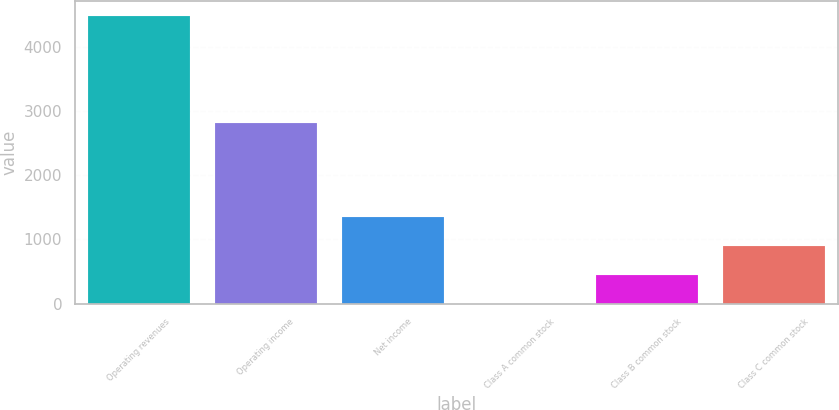Convert chart. <chart><loc_0><loc_0><loc_500><loc_500><bar_chart><fcel>Operating revenues<fcel>Operating income<fcel>Net income<fcel>Class A common stock<fcel>Class B common stock<fcel>Class C common stock<nl><fcel>4477<fcel>2808<fcel>1343.22<fcel>0.18<fcel>447.86<fcel>895.54<nl></chart> 